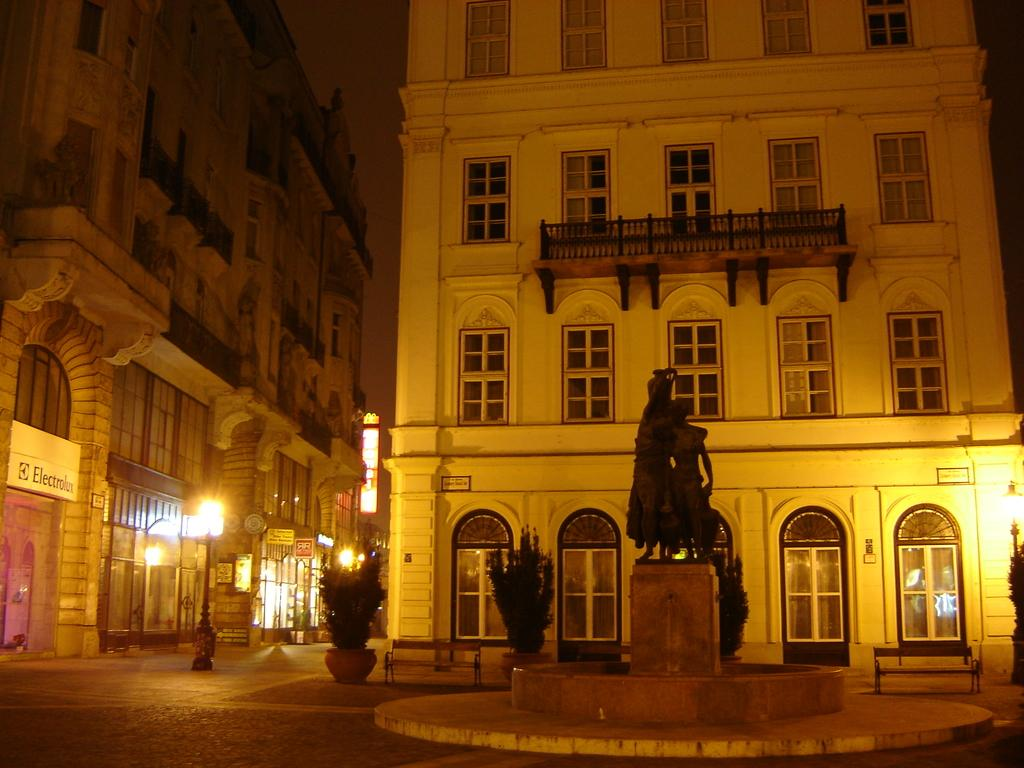What is located in the center of the image? There are buildings in the center of the image. What is at the bottom of the image? There is a statue at the bottom of the image. How is the statue positioned in the image? The statue is on a pedestal. What type of vegetation can be seen in the image? There are bushes in the image. What can be seen in the background of the image? There are poles and lights in the background of the image. What type of paper is wrapped around the parcel in the image? There is no parcel or paper present in the image. 